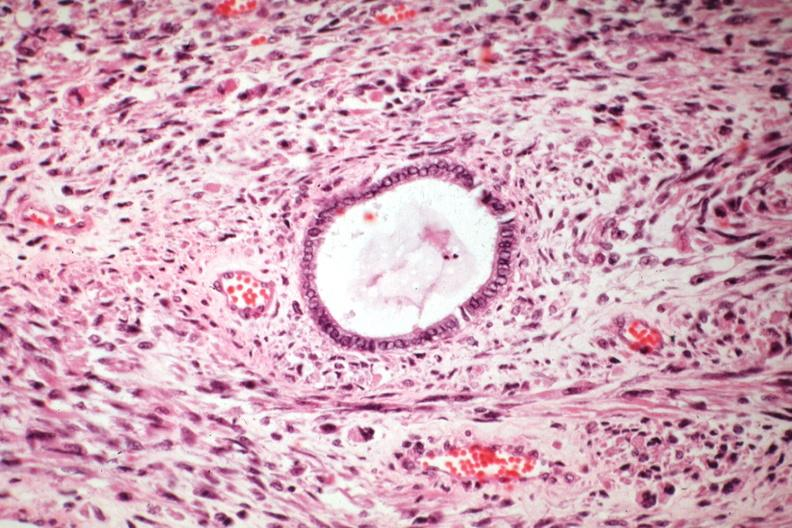where is this from?
Answer the question using a single word or phrase. Female reproductive system 